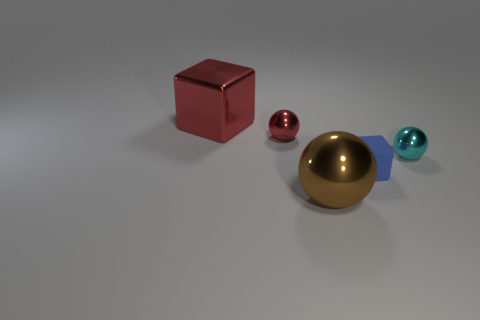Is there any other thing that has the same material as the small blue block?
Offer a terse response. No. There is a large thing that is behind the small shiny sphere on the right side of the brown object; what number of big red things are to the left of it?
Your response must be concise. 0. Are there any red shiny blocks right of the large brown shiny sphere?
Keep it short and to the point. No. What shape is the brown shiny object?
Provide a short and direct response. Sphere. What shape is the tiny metal thing that is on the left side of the big object in front of the cube that is behind the cyan metal object?
Provide a short and direct response. Sphere. What number of other things are there of the same shape as the brown thing?
Ensure brevity in your answer.  2. There is a cube on the right side of the red block that is behind the tiny blue matte cube; what is it made of?
Provide a short and direct response. Rubber. Are the brown sphere and the big thing that is behind the tiny blue matte thing made of the same material?
Provide a succinct answer. Yes. There is a object that is both in front of the tiny cyan metal object and on the left side of the tiny matte cube; what is its material?
Offer a terse response. Metal. The object that is right of the cube that is to the right of the small red sphere is what color?
Your answer should be compact. Cyan. 